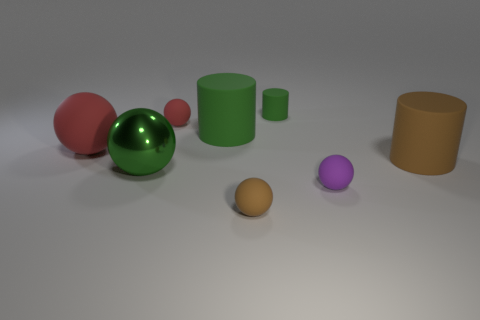The matte thing that is the same color as the tiny rubber cylinder is what shape?
Offer a very short reply. Cylinder. Is there anything else that is the same shape as the big green rubber object?
Offer a terse response. Yes. Is the number of cylinders less than the number of big purple rubber things?
Your answer should be compact. No. There is a big thing that is left of the purple rubber object and on the right side of the green shiny ball; what is it made of?
Give a very brief answer. Rubber. Are there any small rubber objects that are behind the big rubber cylinder that is right of the small green cylinder?
Ensure brevity in your answer.  Yes. How many objects are small purple matte things or small cyan spheres?
Give a very brief answer. 1. There is a small rubber object that is both behind the big green metallic ball and to the right of the big green cylinder; what shape is it?
Offer a terse response. Cylinder. Do the brown thing that is behind the metal ball and the small green object have the same material?
Offer a very short reply. Yes. What number of things are either brown matte objects or big things that are behind the big shiny thing?
Your answer should be very brief. 4. There is a small cylinder that is made of the same material as the brown ball; what is its color?
Provide a succinct answer. Green. 